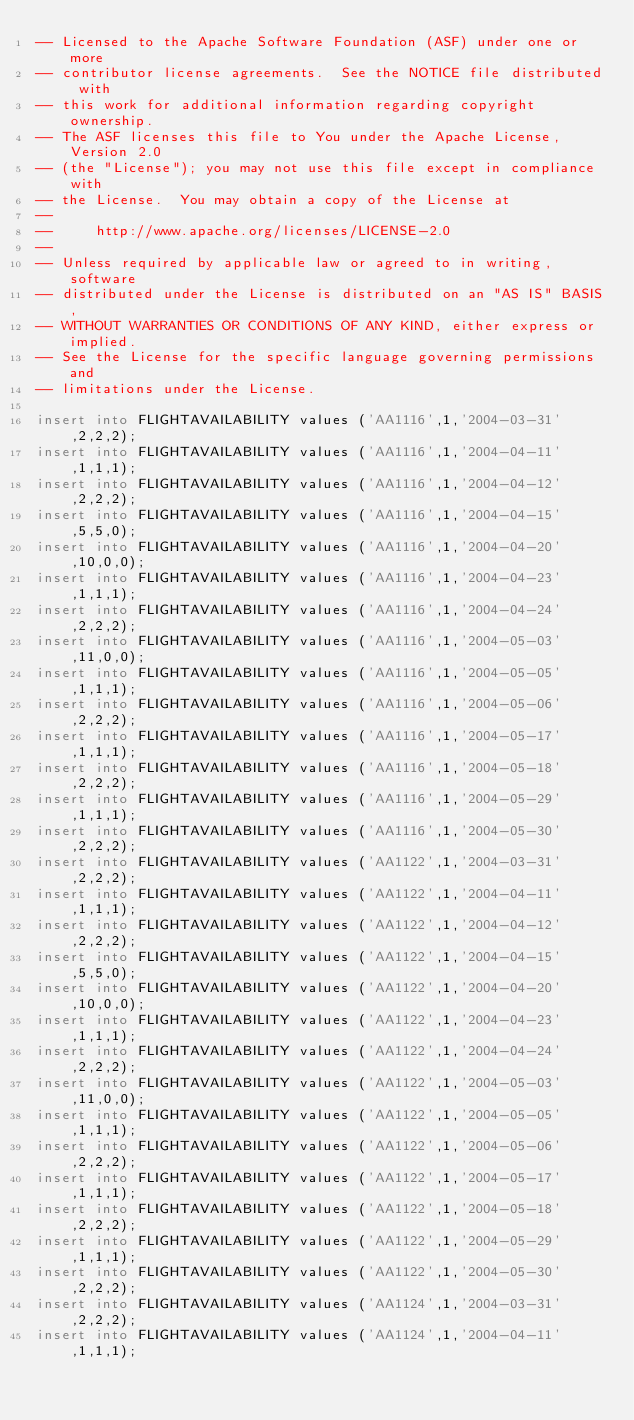<code> <loc_0><loc_0><loc_500><loc_500><_SQL_>-- Licensed to the Apache Software Foundation (ASF) under one or more
-- contributor license agreements.  See the NOTICE file distributed with
-- this work for additional information regarding copyright ownership.
-- The ASF licenses this file to You under the Apache License, Version 2.0
-- (the "License"); you may not use this file except in compliance with
-- the License.  You may obtain a copy of the License at
--
--     http://www.apache.org/licenses/LICENSE-2.0
--
-- Unless required by applicable law or agreed to in writing, software
-- distributed under the License is distributed on an "AS IS" BASIS,
-- WITHOUT WARRANTIES OR CONDITIONS OF ANY KIND, either express or implied.
-- See the License for the specific language governing permissions and
-- limitations under the License.

insert into FLIGHTAVAILABILITY values ('AA1116',1,'2004-03-31',2,2,2); 
insert into FLIGHTAVAILABILITY values ('AA1116',1,'2004-04-11',1,1,1); 
insert into FLIGHTAVAILABILITY values ('AA1116',1,'2004-04-12',2,2,2); 
insert into FLIGHTAVAILABILITY values ('AA1116',1,'2004-04-15',5,5,0); 
insert into FLIGHTAVAILABILITY values ('AA1116',1,'2004-04-20',10,0,0); 
insert into FLIGHTAVAILABILITY values ('AA1116',1,'2004-04-23',1,1,1); 
insert into FLIGHTAVAILABILITY values ('AA1116',1,'2004-04-24',2,2,2); 
insert into FLIGHTAVAILABILITY values ('AA1116',1,'2004-05-03',11,0,0); 
insert into FLIGHTAVAILABILITY values ('AA1116',1,'2004-05-05',1,1,1); 
insert into FLIGHTAVAILABILITY values ('AA1116',1,'2004-05-06',2,2,2); 
insert into FLIGHTAVAILABILITY values ('AA1116',1,'2004-05-17',1,1,1); 
insert into FLIGHTAVAILABILITY values ('AA1116',1,'2004-05-18',2,2,2); 
insert into FLIGHTAVAILABILITY values ('AA1116',1,'2004-05-29',1,1,1); 
insert into FLIGHTAVAILABILITY values ('AA1116',1,'2004-05-30',2,2,2); 
insert into FLIGHTAVAILABILITY values ('AA1122',1,'2004-03-31',2,2,2); 
insert into FLIGHTAVAILABILITY values ('AA1122',1,'2004-04-11',1,1,1); 
insert into FLIGHTAVAILABILITY values ('AA1122',1,'2004-04-12',2,2,2); 
insert into FLIGHTAVAILABILITY values ('AA1122',1,'2004-04-15',5,5,0); 
insert into FLIGHTAVAILABILITY values ('AA1122',1,'2004-04-20',10,0,0); 
insert into FLIGHTAVAILABILITY values ('AA1122',1,'2004-04-23',1,1,1); 
insert into FLIGHTAVAILABILITY values ('AA1122',1,'2004-04-24',2,2,2); 
insert into FLIGHTAVAILABILITY values ('AA1122',1,'2004-05-03',11,0,0); 
insert into FLIGHTAVAILABILITY values ('AA1122',1,'2004-05-05',1,1,1); 
insert into FLIGHTAVAILABILITY values ('AA1122',1,'2004-05-06',2,2,2); 
insert into FLIGHTAVAILABILITY values ('AA1122',1,'2004-05-17',1,1,1); 
insert into FLIGHTAVAILABILITY values ('AA1122',1,'2004-05-18',2,2,2); 
insert into FLIGHTAVAILABILITY values ('AA1122',1,'2004-05-29',1,1,1); 
insert into FLIGHTAVAILABILITY values ('AA1122',1,'2004-05-30',2,2,2); 
insert into FLIGHTAVAILABILITY values ('AA1124',1,'2004-03-31',2,2,2); 
insert into FLIGHTAVAILABILITY values ('AA1124',1,'2004-04-11',1,1,1); </code> 